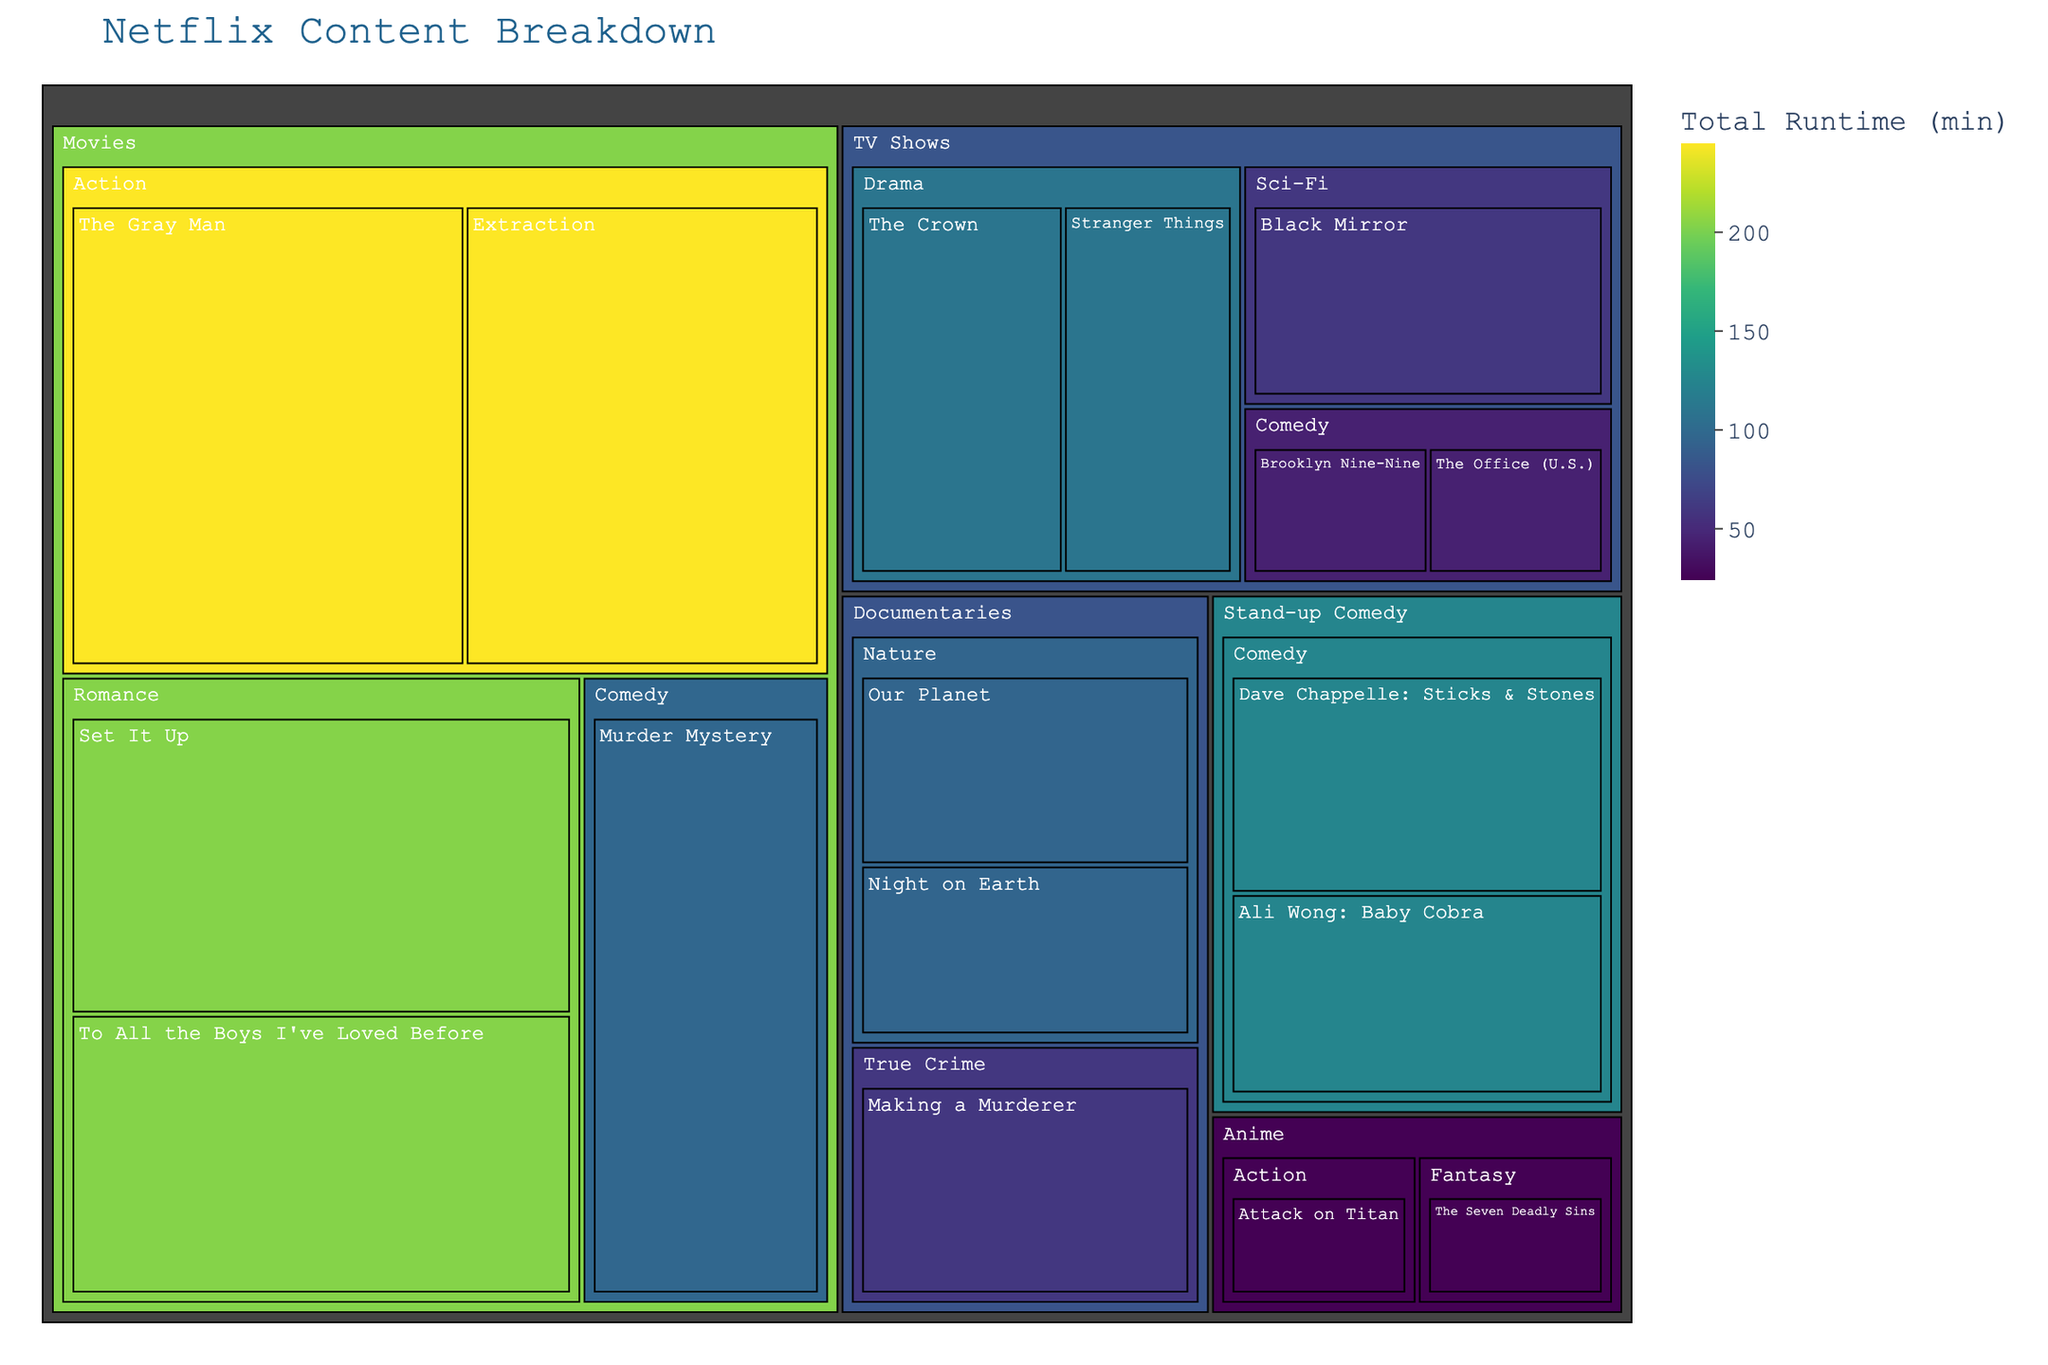what is the title of this figure? The title is usually placed at the top of the figure. Look for the largest text in a prominent position.
Answer: Netflix Content Breakdown Which category has the largest total runtime in this figure? To determine this, you need to look at the top-level categories and compare the size and color of their respective sections. The larger the section and the darker the color, the higher the total runtime.
Answer: TV Shows What is the runtime of "Stranger Things"? Find the "Stranger Things" title in the figure, then look at the runtime specified next to it.
Answer: 50 min Which genre under "TV Shows" has a higher total runtime: Drama or Comedy? Within the "TV Shows" category, compare the sizes and colors of the Drama and Comedy sections. The one with the larger size and darker color has the higher total runtime.
Answer: Drama How many unique genres are represented in the "Movies" category? Locate the "Movies" category and count the distinct genres listed within it.
Answer: 3 What is the total runtime for the "Nature" genre in the "Documentaries" category? Sum the runtimes of the titles listed under the "Nature" genre within "Documentaries". Look for Our Planet (50) and Night on Earth (45). So, 50 + 45 = 95.
Answer: 95 min Which category has the smallest total runtime? Compare the sizes and colors of all top-level category sections. The smallest section with the lightest color has the smallest total runtime.
Answer: Anime What is the runtime of "The Gray Man"? Locate "The Gray Man" in the figure and identify the runtime indicated next to it.
Answer: 129 min Which genre under "Movies" has the highest total runtime? Within the "Movies" category, compare the sizes and colors of each genre section. The genre with the larger section and darker color has the highest total runtime.
Answer: Action How does the total runtime of "Sci-Fi" genre in "TV Shows" compare to "Romance" genre in "Movies"? Compare the sizes and colors of the "Sci-Fi" genre section in "TV Shows" and the "Romance" genre section in "Movies". The larger section with a darker color indicates a higher total runtime.
Answer: Sci-Fi in TV Shows has a higher total runtime than Romance in Movies 